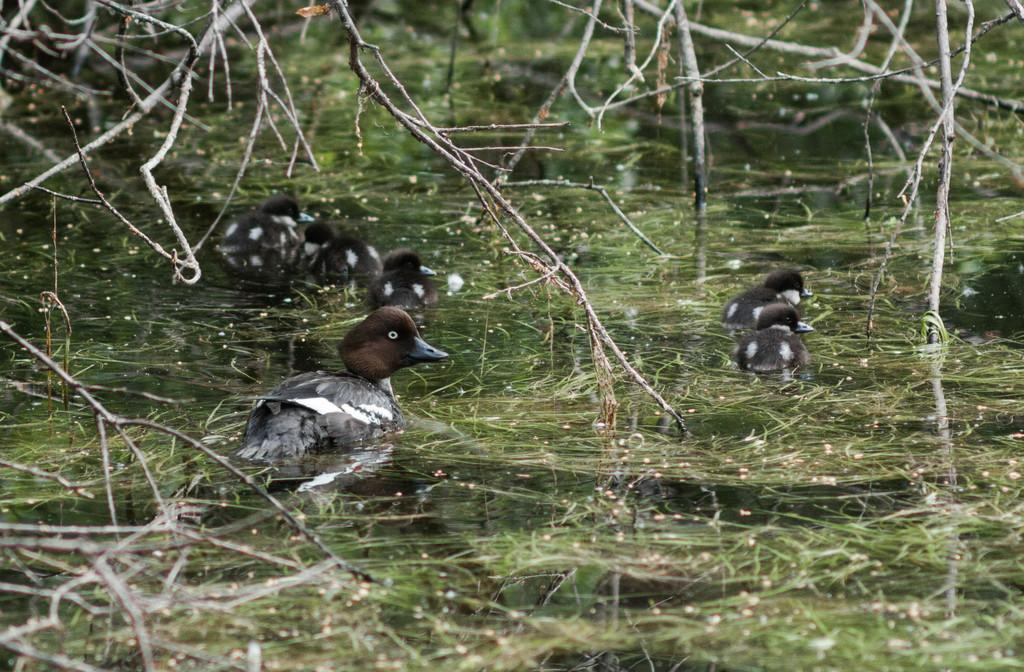What is the primary element visible in the image? There is water in the image. What type of animals can be seen in the image? Birds can be seen in the image. What natural objects are present in the image? Dried branches are present in the image. What type of digestion can be observed in the image? There is no digestion present in the image; it features water, birds, and dried branches. Is there a volcano visible in the image? There is no volcano present in the image. 